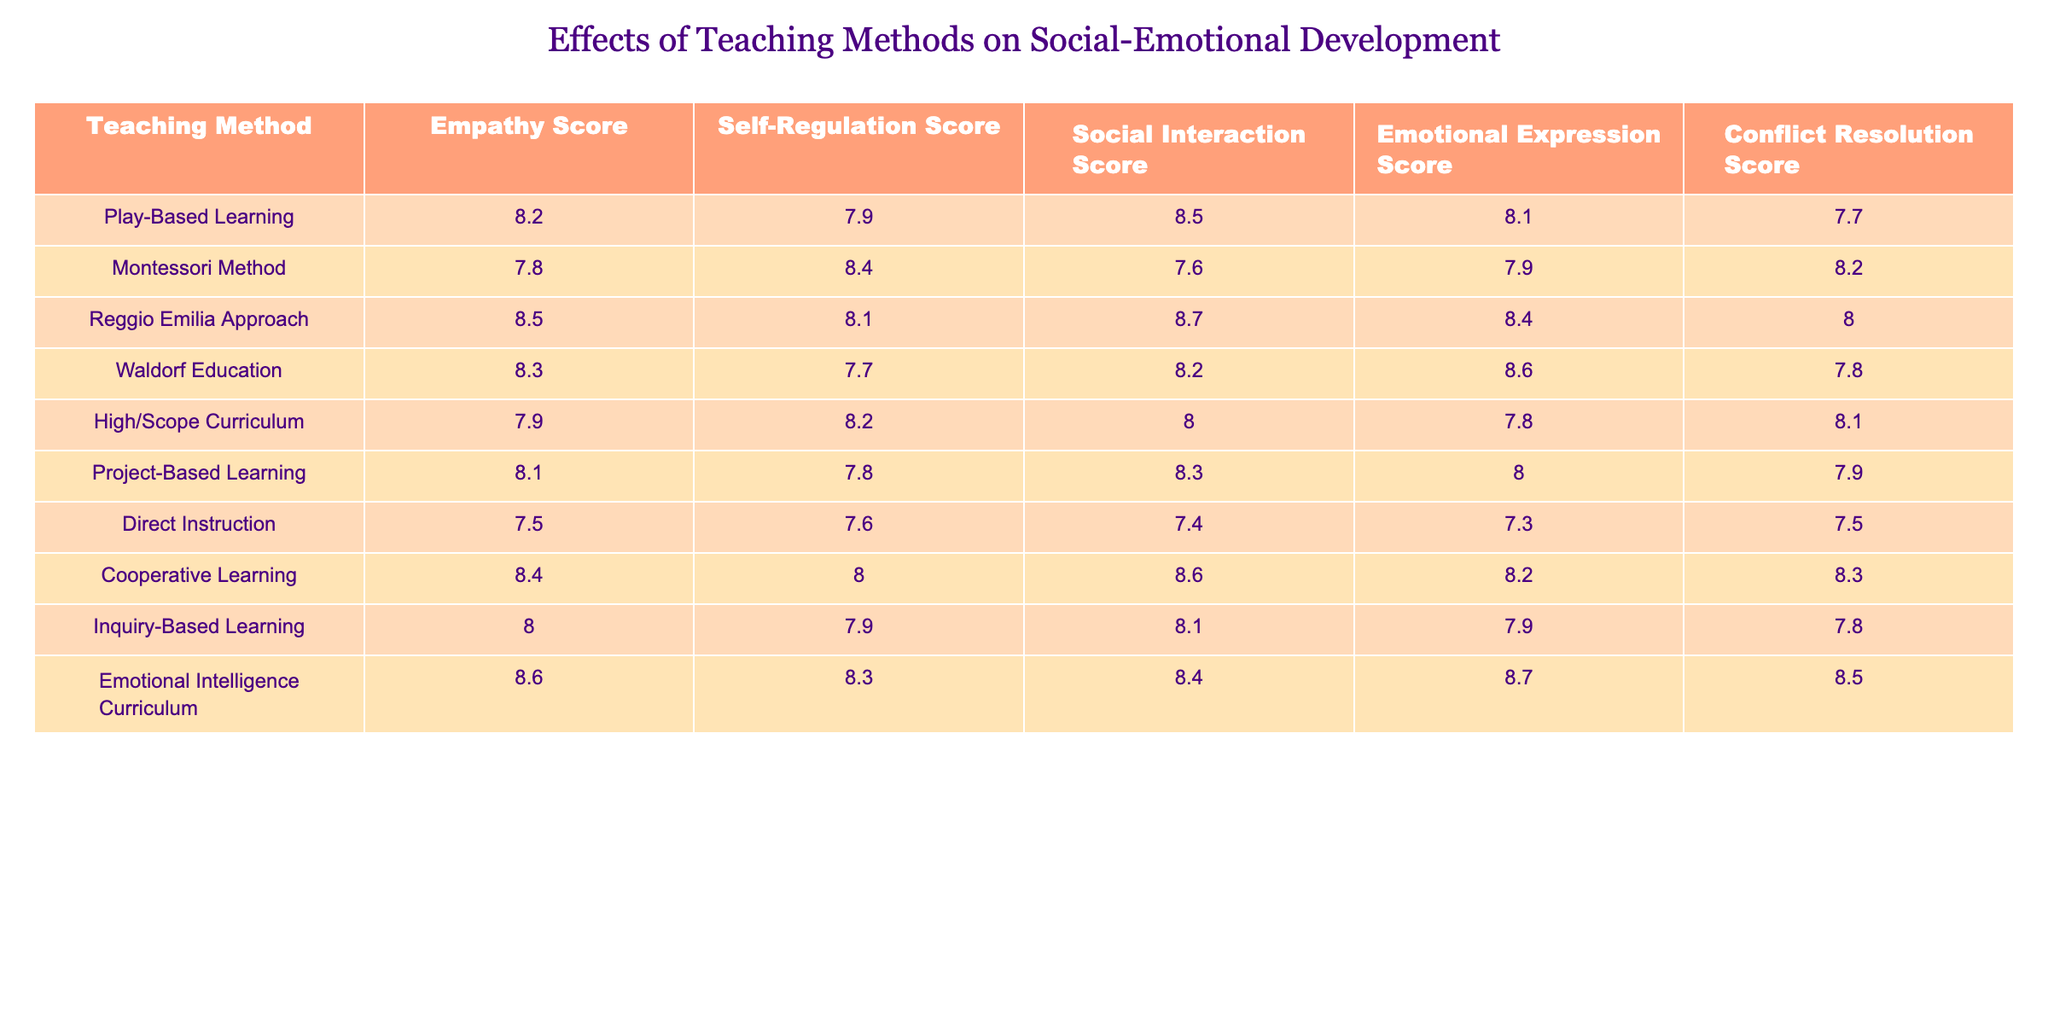What is the empathy score for the Inquiry-Based Learning method? The empathy score for Inquiry-Based Learning is listed directly in the table. Looking at the row for Inquiry-Based Learning, the empathy score is 8.0.
Answer: 8.0 Which teaching method has the highest Emotional Expression Score? The Emotional Expression Scores are compared across the different teaching methods listed. The highest value in the Emotional Expression Score column is 8.7, which corresponds to the Emotional Intelligence Curriculum.
Answer: Emotional Intelligence Curriculum What is the average Self-Regulation Score across all teaching methods? First, we sum the Self-Regulation Scores: (7.9 + 8.4 + 8.1 + 7.7 + 8.2 + 7.8 + 7.6 + 8.0 + 7.9 + 8.3) = 78.0. Then, we divide by the number of teaching methods (10): 78.0 / 10 = 7.8.
Answer: 7.8 True or False: The Direct Instruction method has a higher Conflict Resolution Score than the Montessori Method. By comparing the Conflict Resolution Scores, Direct Instruction has a score of 7.5 while Montessori Method has a score of 8.2. Since 7.5 is less than 8.2, the statement is false.
Answer: False Which teaching method shows the best overall scores in social-emotional development? To determine this, we should look at all the scores for each teaching method and assess which has the highest combined performance. The Emotional Intelligence Curriculum has the highest scores across all categories, with 8.6, 8.3, 8.4, 8.7, and 8.5, which leads to the conclusion that it performs the best overall.
Answer: Emotional Intelligence Curriculum What is the difference between the highest and lowest Social Interaction Scores? The highest Social Interaction Score is 8.7 (Reggio Emilia Approach), and the lowest score is 7.4 (Direct Instruction). The difference is calculated as 8.7 - 7.4 = 1.3.
Answer: 1.3 What is the rank of the Play-Based Learning method in terms of Conflict Resolution Score? By checking the Conflict Resolution Scores, we can see that Play-Based Learning has a score of 7.7, which is the fourth highest score when ordered from highest to lowest. Thus, Play-Based Learning ranks fourth.
Answer: Fourth Which two teaching methods have the most similar Self-Regulation Scores? By examining the Self-Regulation Scores, we see that Montessori Method (8.4) and Cooperative Learning (8.0) have the closest scores. The difference between them is only 0.4, which indicates they are quite similar compared to the other methods.
Answer: Montessori Method and Cooperative Learning What is the total score for Social Interaction across all teaching methods? We add the Social Interaction Scores from the table: (8.5 + 7.6 + 8.7 + 8.2 + 8.0 + 8.3 + 7.4 + 8.6 + 8.1 + 8.4) = 85.4. Therefore, the total score for Social Interaction is 85.4.
Answer: 85.4 Who are the top three teaching methods based on overall average scores across all categories? To find this, we need to calculate the average score for each method by summing their scores and dividing by 5. The top three with the respective averages are: Emotional Intelligence Curriculum (8.5), Reggio Emilia Approach (8.34), and Play-Based Learning (8.1).
Answer: Emotional Intelligence Curriculum, Reggio Emilia Approach, Play-Based Learning 